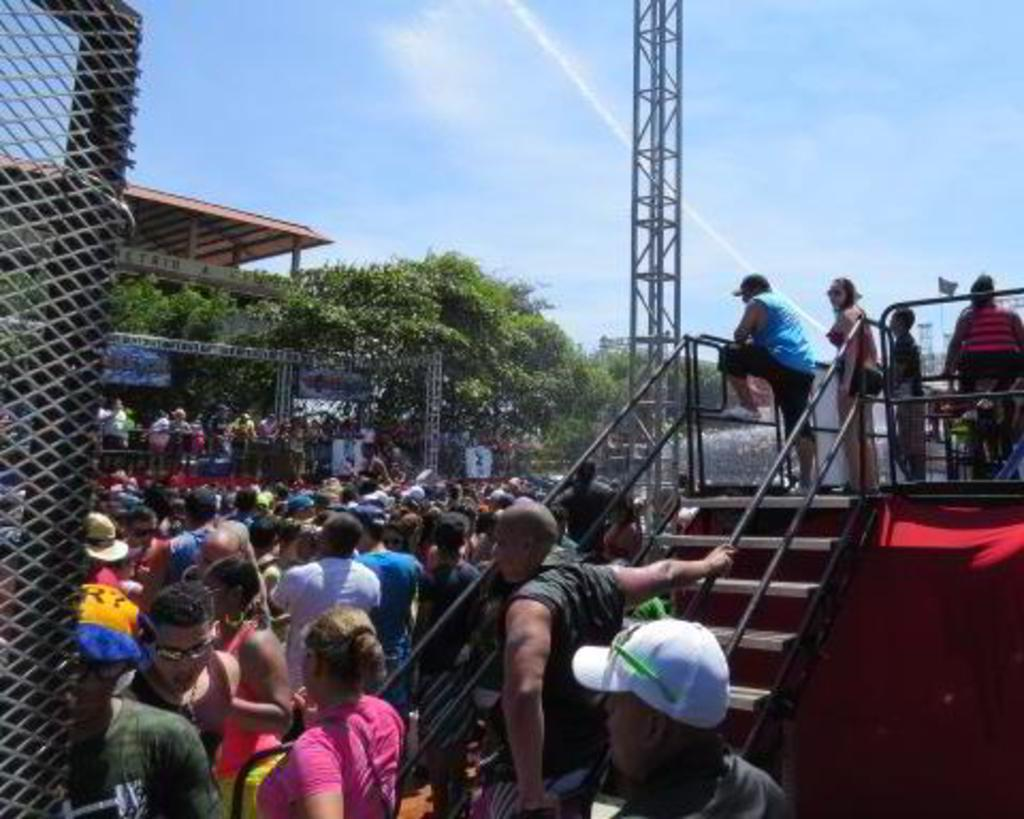What can be seen in the image? There are people, a staircase, a stage, a mesh, trees, and people in the background, a tower, a roof, and the sky visible in the background of the image. Can you describe the location of the stage in the image? The stage is in the image, but the specific location is not mentioned in the facts. What type of structure is visible in the background of the image? There is a tower in the background of the image. What is the weather like in the image? The sky is visible in the background of the image, but the weather cannot be determined from the facts provided. What type of bean is being used as a rhythm instrument by the people in the image? There is no mention of beans or rhythm instruments in the image. 